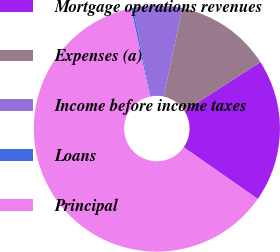Convert chart. <chart><loc_0><loc_0><loc_500><loc_500><pie_chart><fcel>Mortgage operations revenues<fcel>Expenses (a)<fcel>Income before income taxes<fcel>Loans<fcel>Principal<nl><fcel>18.77%<fcel>12.6%<fcel>6.43%<fcel>0.26%<fcel>61.94%<nl></chart> 